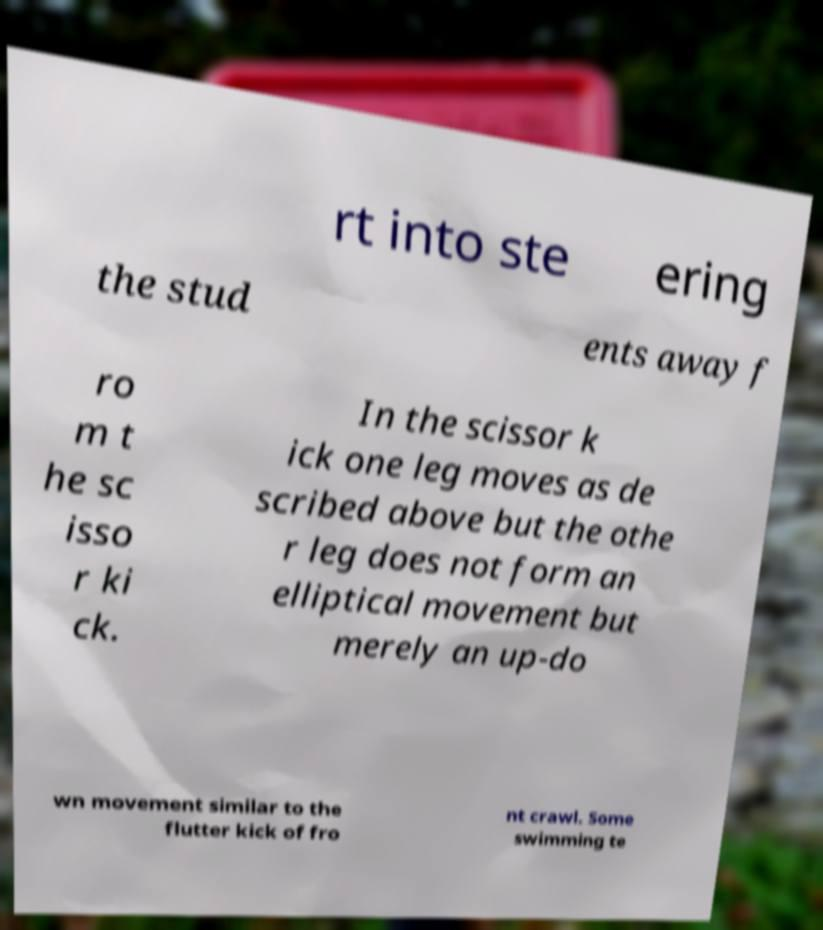Could you extract and type out the text from this image? rt into ste ering the stud ents away f ro m t he sc isso r ki ck. In the scissor k ick one leg moves as de scribed above but the othe r leg does not form an elliptical movement but merely an up-do wn movement similar to the flutter kick of fro nt crawl. Some swimming te 